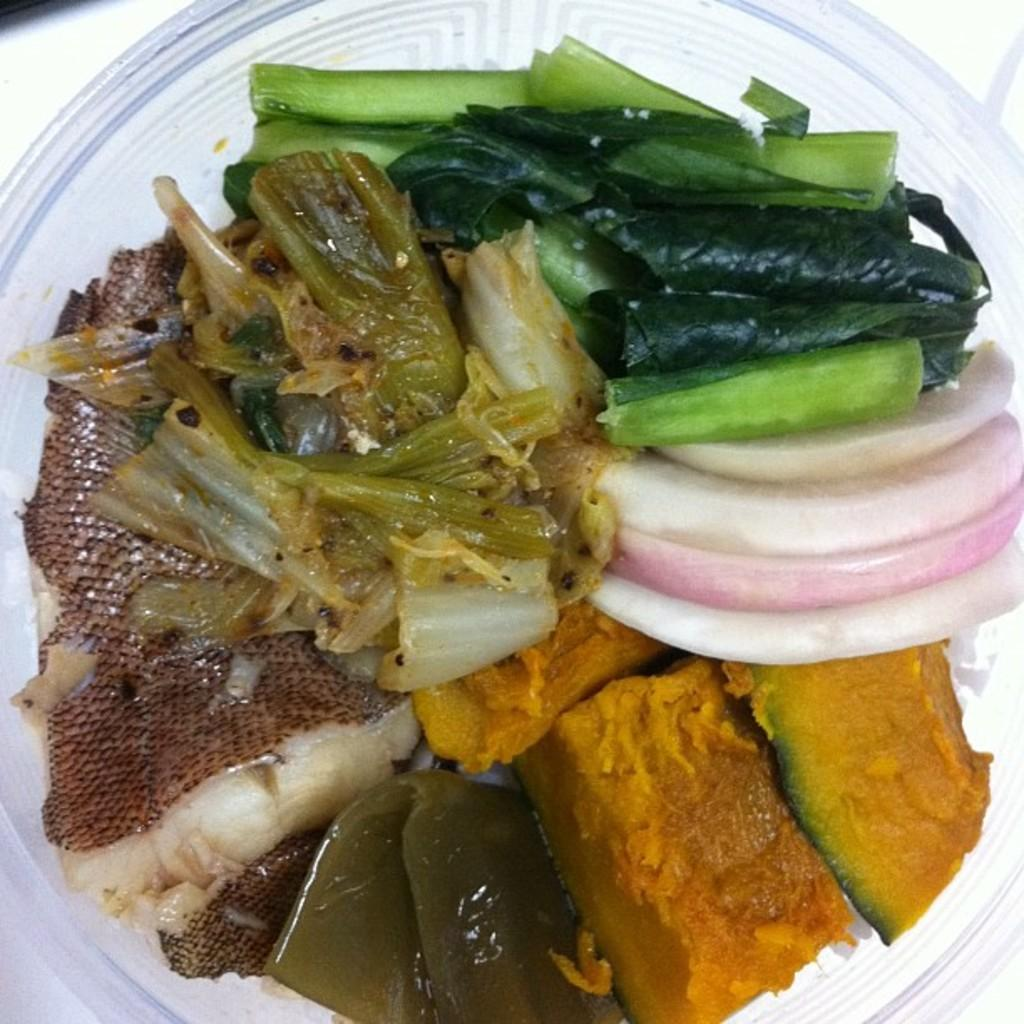What is present on the plate in the image? There is food in a plate in the image. What type of plantation can be seen in the background of the image? There is no plantation present in the image; it only shows food in a plate. 